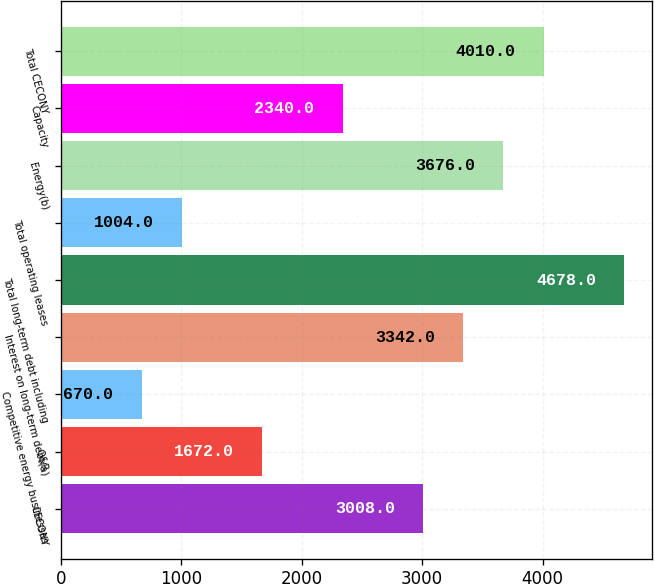Convert chart to OTSL. <chart><loc_0><loc_0><loc_500><loc_500><bar_chart><fcel>CECONY<fcel>O&R<fcel>Competitive energy businesses<fcel>Interest on long-term debt(a)<fcel>Total long-term debt including<fcel>Total operating leases<fcel>Energy(b)<fcel>Capacity<fcel>Total CECONY<nl><fcel>3008<fcel>1672<fcel>670<fcel>3342<fcel>4678<fcel>1004<fcel>3676<fcel>2340<fcel>4010<nl></chart> 